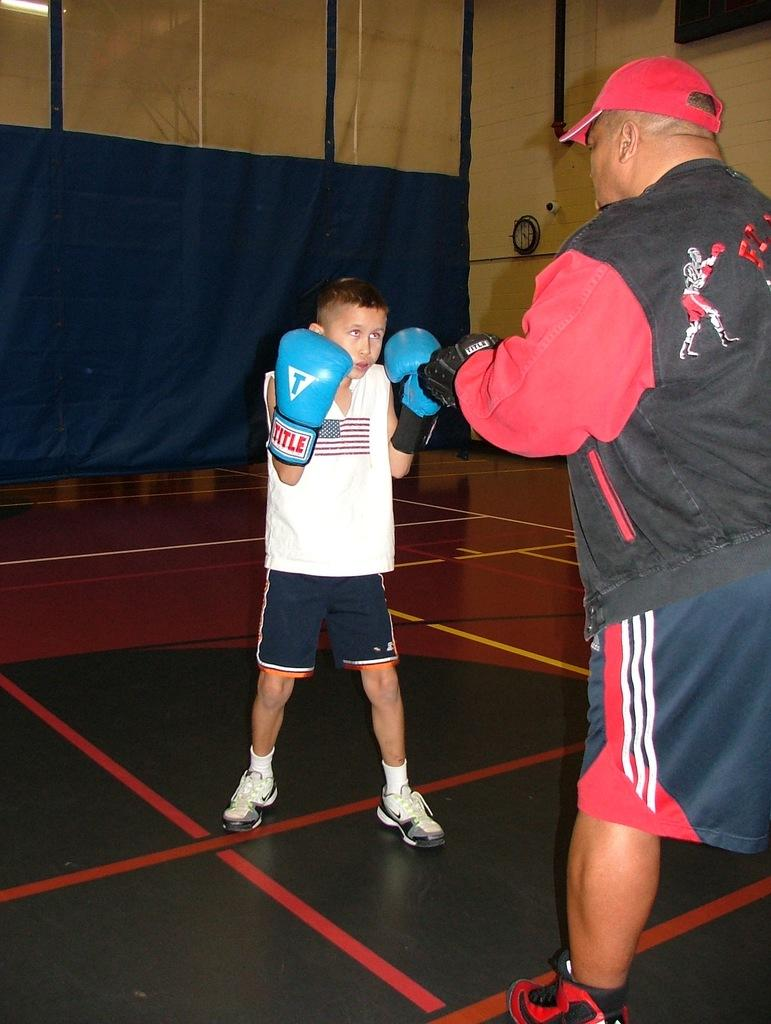Who is on the right side of the image? There is a person on the right side of the image. What is the main subject in the middle of the image? There is a kid in the middle of the image. What is the kid wearing on their hands? The kid is wearing gloves. What is at the bottom of the image? There appears to be a mat at the bottom of the image. What can be seen in the background of the image? There is a wall visible in the background of the image, along with other objects. Can you tell me how many snails are crawling on the wall in the image? There are no snails present in the image; only a person, a kid, gloves, a mat, a wall, and other objects are visible. What type of pen is the kid using to draw on the mat? There is no pen visible in the image; the kid is wearing gloves. 